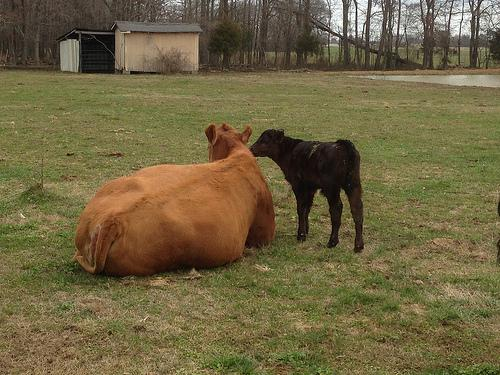Question: where are the cows?
Choices:
A. In the pasture.
B. A field.
C. In the woods.
D. In a pen.
Answer with the letter. Answer: B Question: what color is the smallest cow?
Choices:
A. Brown.
B. Black.
C. White.
D. Tan.
Answer with the letter. Answer: B Question: what is in the background?
Choices:
A. A building.
B. A home.
C. A barn.
D. A pen.
Answer with the letter. Answer: C Question: who is in this picture?
Choices:
A. Bulls.
B. Horses.
C. Pigs.
D. Cows.
Answer with the letter. Answer: D Question: how many cows are there?
Choices:
A. Three.
B. Two.
C. Four.
D. Five.
Answer with the letter. Answer: B 